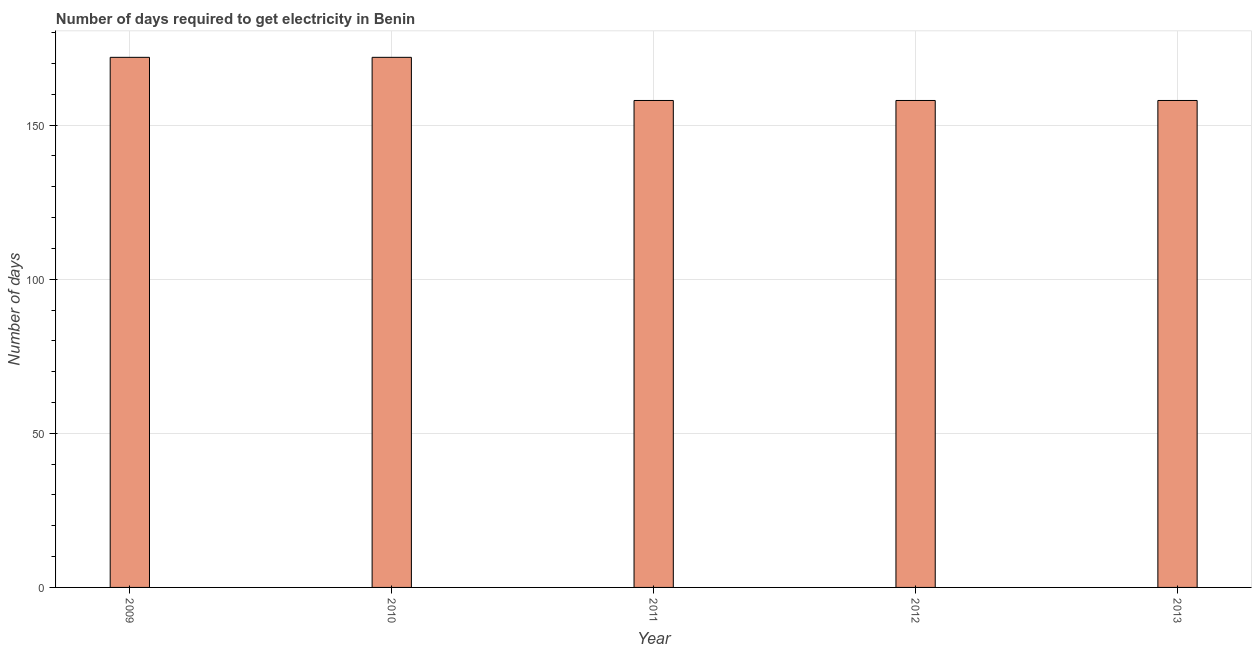What is the title of the graph?
Offer a very short reply. Number of days required to get electricity in Benin. What is the label or title of the Y-axis?
Your answer should be very brief. Number of days. What is the time to get electricity in 2011?
Provide a succinct answer. 158. Across all years, what is the maximum time to get electricity?
Your response must be concise. 172. Across all years, what is the minimum time to get electricity?
Offer a very short reply. 158. What is the sum of the time to get electricity?
Keep it short and to the point. 818. What is the difference between the time to get electricity in 2009 and 2011?
Your answer should be very brief. 14. What is the average time to get electricity per year?
Keep it short and to the point. 163. What is the median time to get electricity?
Provide a short and direct response. 158. In how many years, is the time to get electricity greater than 160 ?
Keep it short and to the point. 2. Do a majority of the years between 2011 and 2010 (inclusive) have time to get electricity greater than 70 ?
Offer a very short reply. No. Is the time to get electricity in 2009 less than that in 2011?
Offer a very short reply. No. Is the difference between the time to get electricity in 2010 and 2012 greater than the difference between any two years?
Make the answer very short. Yes. Is the sum of the time to get electricity in 2009 and 2012 greater than the maximum time to get electricity across all years?
Your answer should be compact. Yes. What is the difference between the highest and the lowest time to get electricity?
Ensure brevity in your answer.  14. How many bars are there?
Keep it short and to the point. 5. What is the Number of days of 2009?
Offer a very short reply. 172. What is the Number of days of 2010?
Provide a short and direct response. 172. What is the Number of days of 2011?
Your response must be concise. 158. What is the Number of days of 2012?
Your answer should be very brief. 158. What is the Number of days in 2013?
Your answer should be compact. 158. What is the difference between the Number of days in 2009 and 2010?
Offer a terse response. 0. What is the difference between the Number of days in 2009 and 2011?
Provide a succinct answer. 14. What is the difference between the Number of days in 2010 and 2011?
Offer a very short reply. 14. What is the difference between the Number of days in 2010 and 2012?
Your response must be concise. 14. What is the difference between the Number of days in 2011 and 2013?
Ensure brevity in your answer.  0. What is the ratio of the Number of days in 2009 to that in 2011?
Your response must be concise. 1.09. What is the ratio of the Number of days in 2009 to that in 2012?
Offer a very short reply. 1.09. What is the ratio of the Number of days in 2009 to that in 2013?
Offer a terse response. 1.09. What is the ratio of the Number of days in 2010 to that in 2011?
Provide a succinct answer. 1.09. What is the ratio of the Number of days in 2010 to that in 2012?
Offer a very short reply. 1.09. What is the ratio of the Number of days in 2010 to that in 2013?
Your response must be concise. 1.09. What is the ratio of the Number of days in 2011 to that in 2012?
Offer a terse response. 1. What is the ratio of the Number of days in 2011 to that in 2013?
Provide a short and direct response. 1. 